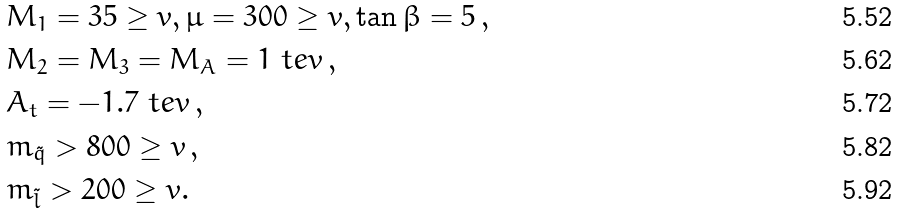Convert formula to latex. <formula><loc_0><loc_0><loc_500><loc_500>& M _ { 1 } = 3 5 \geq v , \mu = 3 0 0 \geq v , \tan \beta = 5 \, , \\ & M _ { 2 } = M _ { 3 } = M _ { A } = 1 \ t e v \, , \\ & A _ { t } = - 1 . 7 \ t e v \, , \\ & m _ { \tilde { q } } > 8 0 0 \geq v \, , \\ & m _ { \tilde { l } } > 2 0 0 \geq v .</formula> 